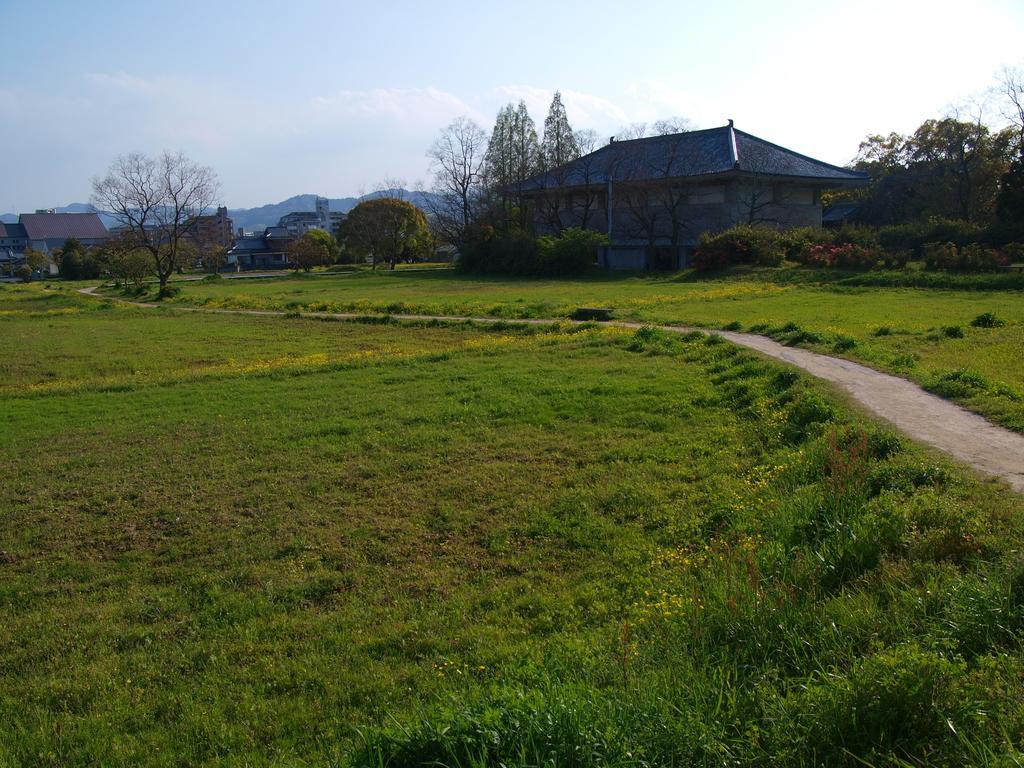Can you describe this image briefly? In this image I can see a ground , on the ground I can see trees and house and at the top I can see the sky and the hill and I can see another hill on the left side. 